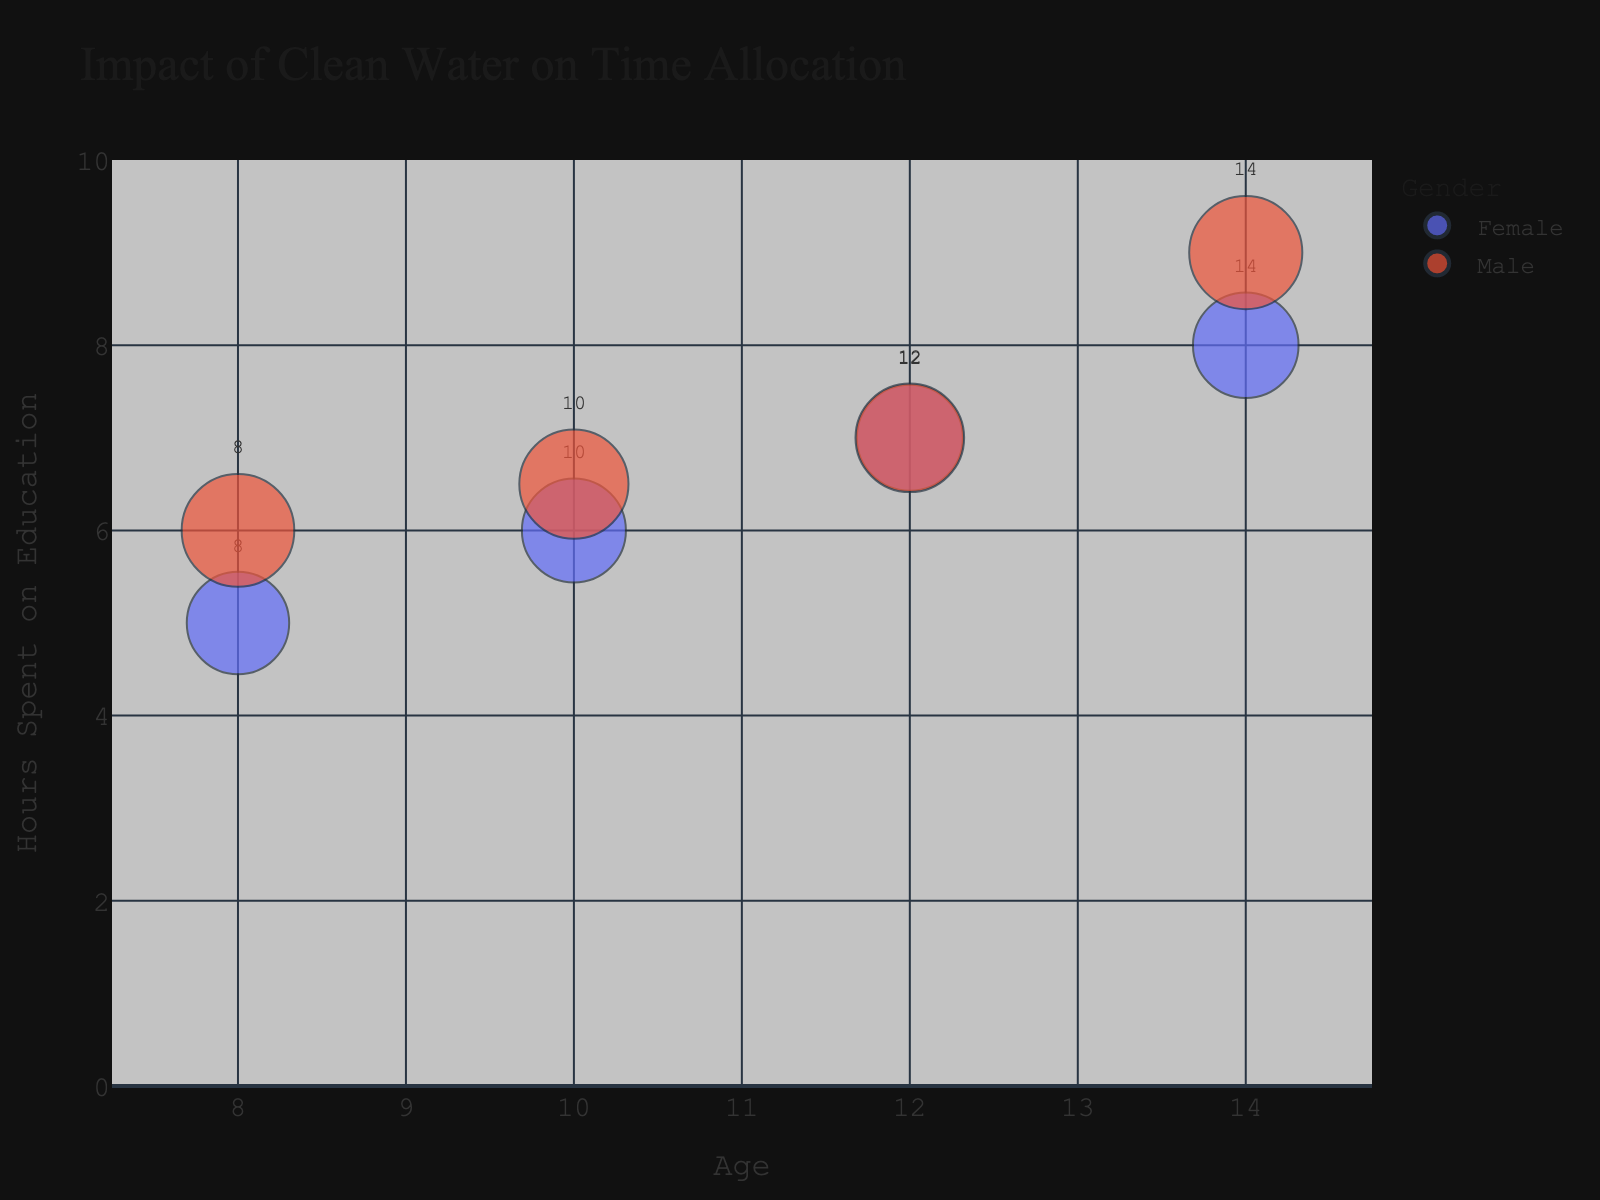How many different age groups are shown in the figure? Identify the number of distinct age points marked on the x-axis. The data includes ages 8, 10, 12, and 14.
Answer: 4 What is the bubble size representing in the figure? Refer to the plot details that mention bubble size. It represents the total hours spent on all activities combined (water collection, education, and play).
Answer: Total hours spent on activities Which gender spends the least amount of time on water collection at age 14? Look at the data points for age 14 and compare Female and Male. Both genders at age 14 spend 0.1 hours on water collection, so it's equal.
Answer: Both What trend can you observe in the daily hours spent on education as age increases? Examine the y-axis values associated with each age point and observe the progression. The hours spent on education consistently increase with age for both genders.
Answer: Increase How does the time spent on education by boys compare to girls at age 10? Compare the y-axis values of the bubbles for boys and girls at age 10. Girls spend 6 hours, while boys spend 6.5 hours on education.
Answer: Boys spend 0.5 hours more What is the overall trend in total hours spent on activities by gender? Analyze the bubble sizes corresponding to the different genders. Boys tend to have slightly larger bubble sizes compared to girls, indicating they spend slightly more total hours on activities.
Answer: Boys larger Which age and gender combination has the highest daily hours spent on education? Identify the data point with the highest y-value for education. The highest is the 14-year-old Male with 9 daily hours spent on education.
Answer: 14-year-old Male What is the difference in daily hours spent on play between 12-year-old boys and girls? Compare the y-axis values for play for both genders at age 12. Boys spend 3.5 hours and girls spend 3, so the difference is 0.5 hours.
Answer: 0.5 hours Which gender shows a greater reduction in daily hours spent on water collection from age 8 to 14? Compare the reductions for both genders from age 8 to 14. Girls reduce from 0.5 to 0.1 (0.4 hours), and boys reduce from 0.5 to 0.1 (0.4 hours). Both show the same reduction.
Answer: Both the same 